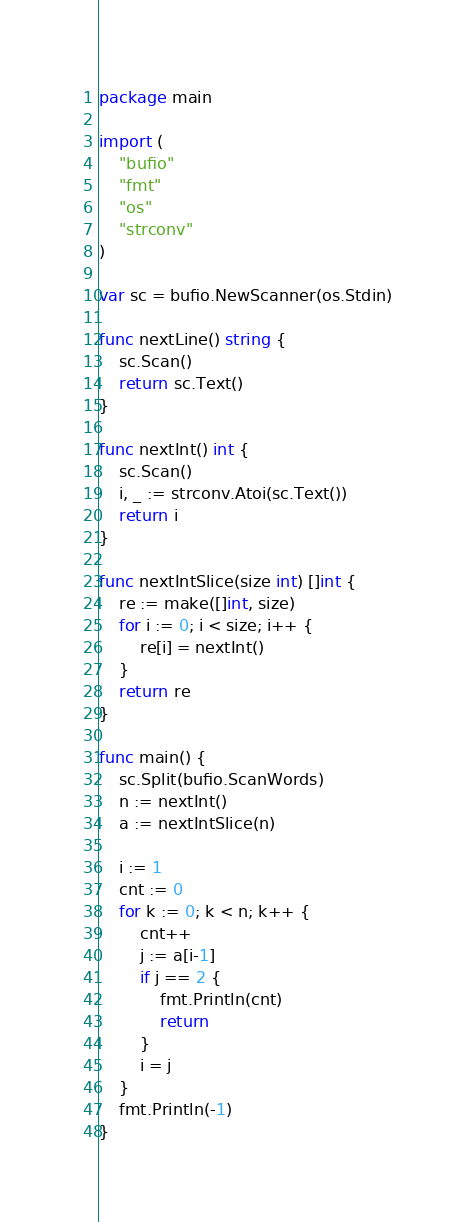Convert code to text. <code><loc_0><loc_0><loc_500><loc_500><_Go_>package main

import (
	"bufio"
	"fmt"
	"os"
	"strconv"
)

var sc = bufio.NewScanner(os.Stdin)

func nextLine() string {
	sc.Scan()
	return sc.Text()
}

func nextInt() int {
	sc.Scan()
	i, _ := strconv.Atoi(sc.Text())
	return i
}

func nextIntSlice(size int) []int {
	re := make([]int, size)
	for i := 0; i < size; i++ {
		re[i] = nextInt()
	}
	return re
}

func main() {
	sc.Split(bufio.ScanWords)
	n := nextInt()
	a := nextIntSlice(n)

	i := 1
	cnt := 0
	for k := 0; k < n; k++ {
		cnt++
		j := a[i-1]
		if j == 2 {
			fmt.Println(cnt)
			return
		}
		i = j
	}
	fmt.Println(-1)
}
</code> 